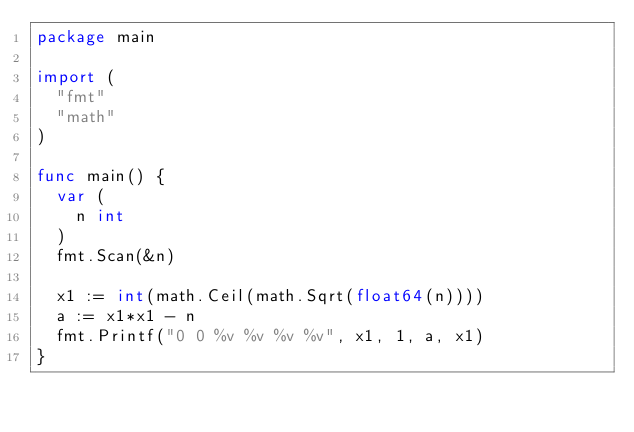Convert code to text. <code><loc_0><loc_0><loc_500><loc_500><_Go_>package main

import (
	"fmt"
	"math"
)

func main() {
	var (
		n int
	)
	fmt.Scan(&n)

	x1 := int(math.Ceil(math.Sqrt(float64(n))))
	a := x1*x1 - n
	fmt.Printf("0 0 %v %v %v %v", x1, 1, a, x1)
}
</code> 